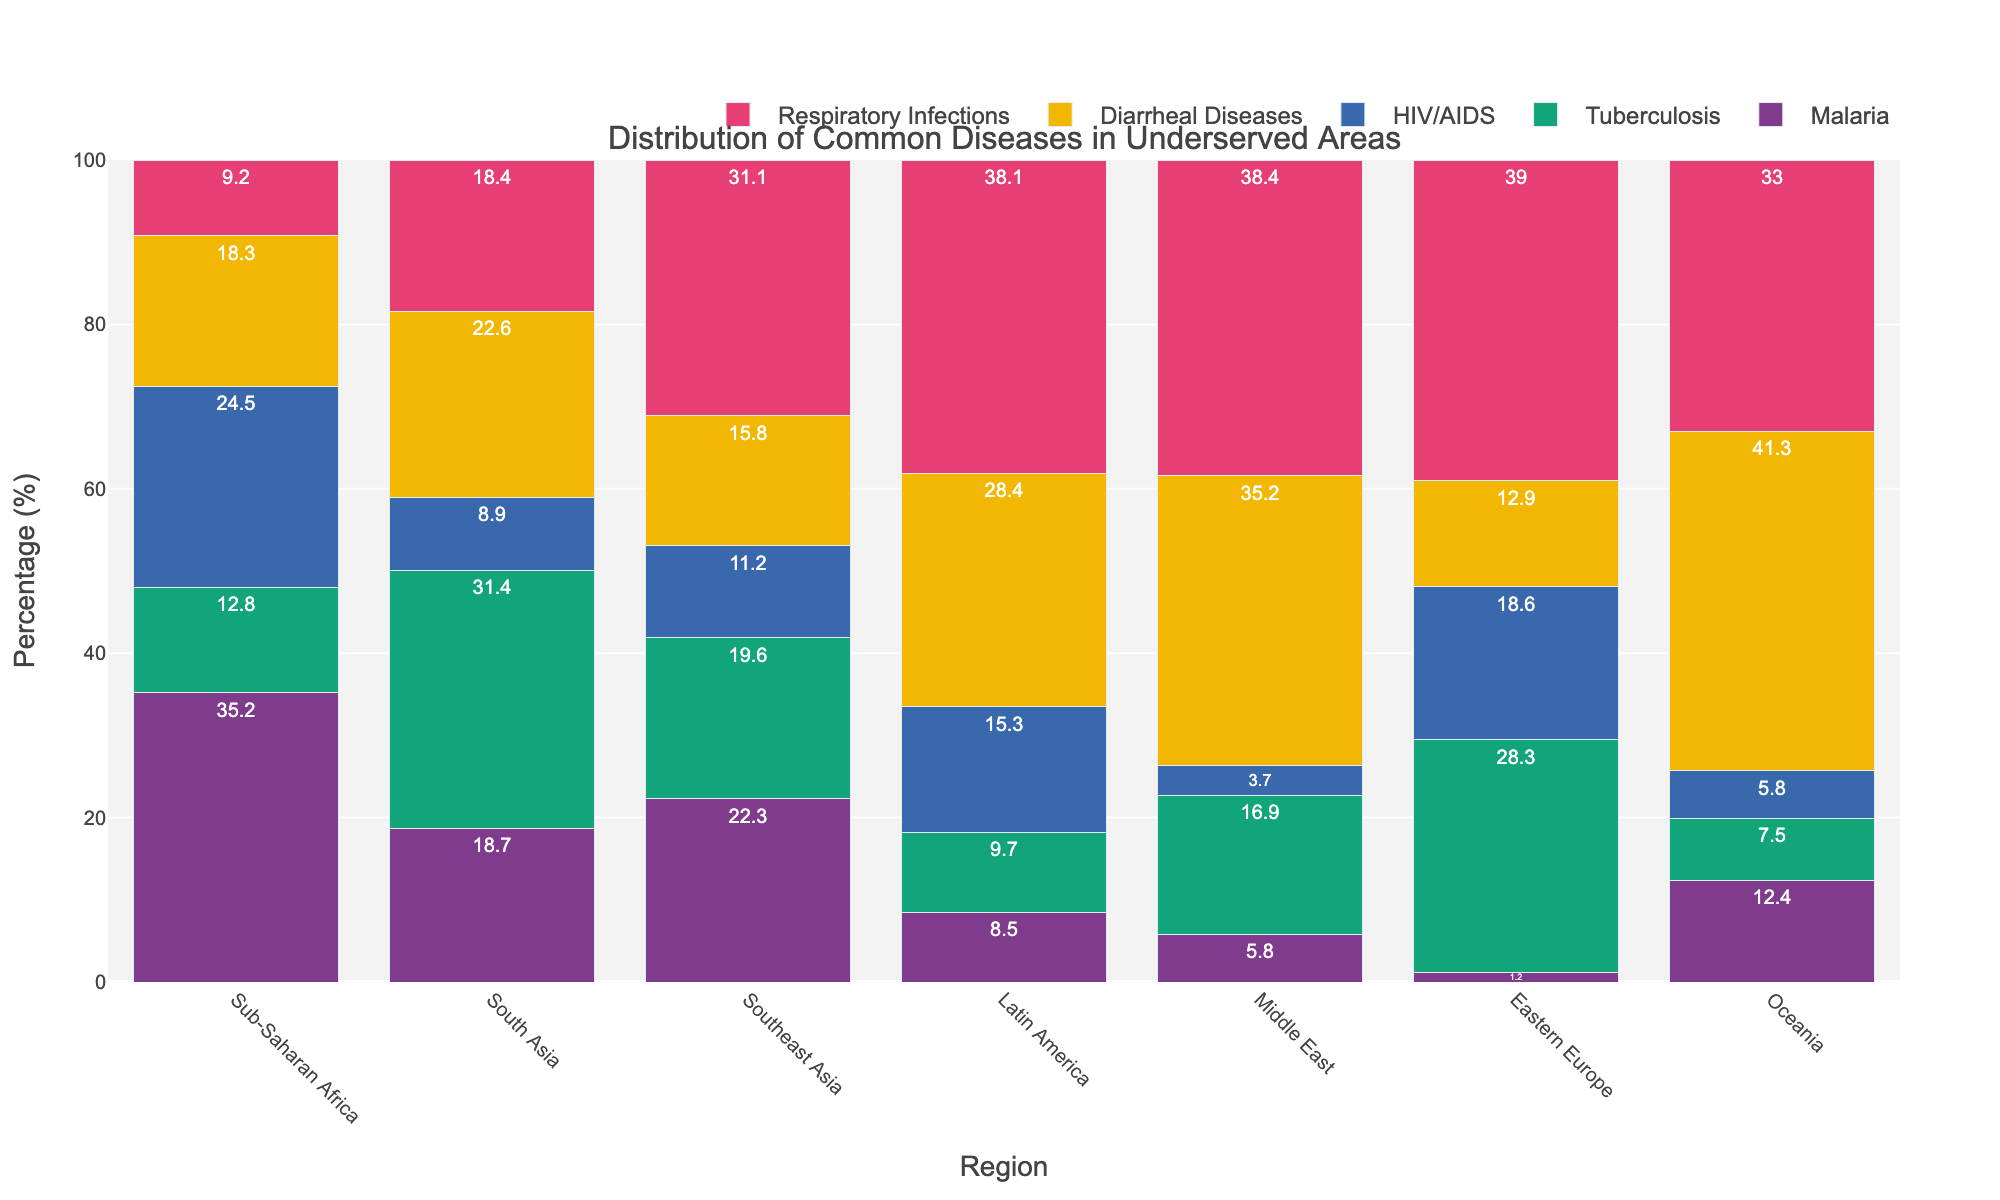Which region has the highest percentage of Malaria cases? Looking at the bar associated with Malaria, the tallest bar is in the Sub-Saharan Africa region.
Answer: Sub-Saharan Africa Which disease has the highest percentage in Eastern Europe? Comparing the heights of the bars within the Eastern Europe region, Respiratory Infections has the tallest bar.
Answer: Respiratory Infections How does the percentage of Tuberculosis in South Asia compare to Sub-Saharan Africa? The bar for Tuberculosis in South Asia is higher than that in Sub-Saharan Africa. In numbers, South Asia has 31.4% whereas Sub-Saharan Africa has 12.8%.
Answer: South Asia has a higher percentage What is the combined percentage of Diarrheal Diseases and Respiratory Infections in Oceania? Summing the percentages from Oceania: Diarrheal Diseases (41.3%) + Respiratory Infections (33%) = 74.3%.
Answer: 74.3% Which region has the lowest percentage of HIV/AIDS, and what is that percentage? By comparing the heights of the HIV/AIDS bars, the Middle East has the shortest bar, which is 3.7%.
Answer: Middle East, 3.7% Between Southeast Asia and Latin America, which region has a higher percentage of Respiratory Infections? Observing the bars for Respiratory Infections, Latin America has a higher bar than Southeast Asia. In numbers, Latin America has 38.1% whereas Southeast Asia has 31.1%.
Answer: Latin America What is the difference in percentage of Diarrheal Diseases between Latin America and the Middle East? Subtracting the value for the Middle East from Latin America: 35.2% - 28.4% = 6.8%.
Answer: 6.8% If we average the percentages of Malaria across all regions, what is the result? Summing up the percentages for Malaria and dividing by the number of regions: (35.2 + 18.7 + 22.3 + 8.5 + 5.8 + 1.2 + 12.4) / 7 ≈ 14.877%.
Answer: 14.9% Which disease has the most even distribution across all regions? By visually inspecting the heights of bars for each disease across all regions, Tuberculosis appears to have relatively even distribution.
Answer: Tuberculosis 